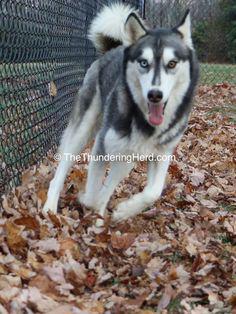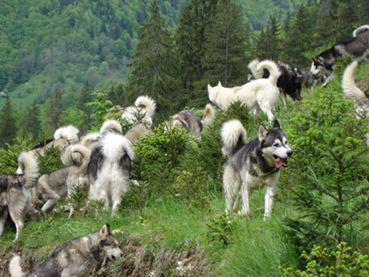The first image is the image on the left, the second image is the image on the right. For the images shown, is this caption "Ini at least one image there is a white and dark husky standing with its tongue hanging out." true? Answer yes or no. Yes. The first image is the image on the left, the second image is the image on the right. Considering the images on both sides, is "Each image contains one dog, and one of the dogs depicted is a husky standing in profile on grass, with white around its eyes and its tail curled inward." valid? Answer yes or no. No. 